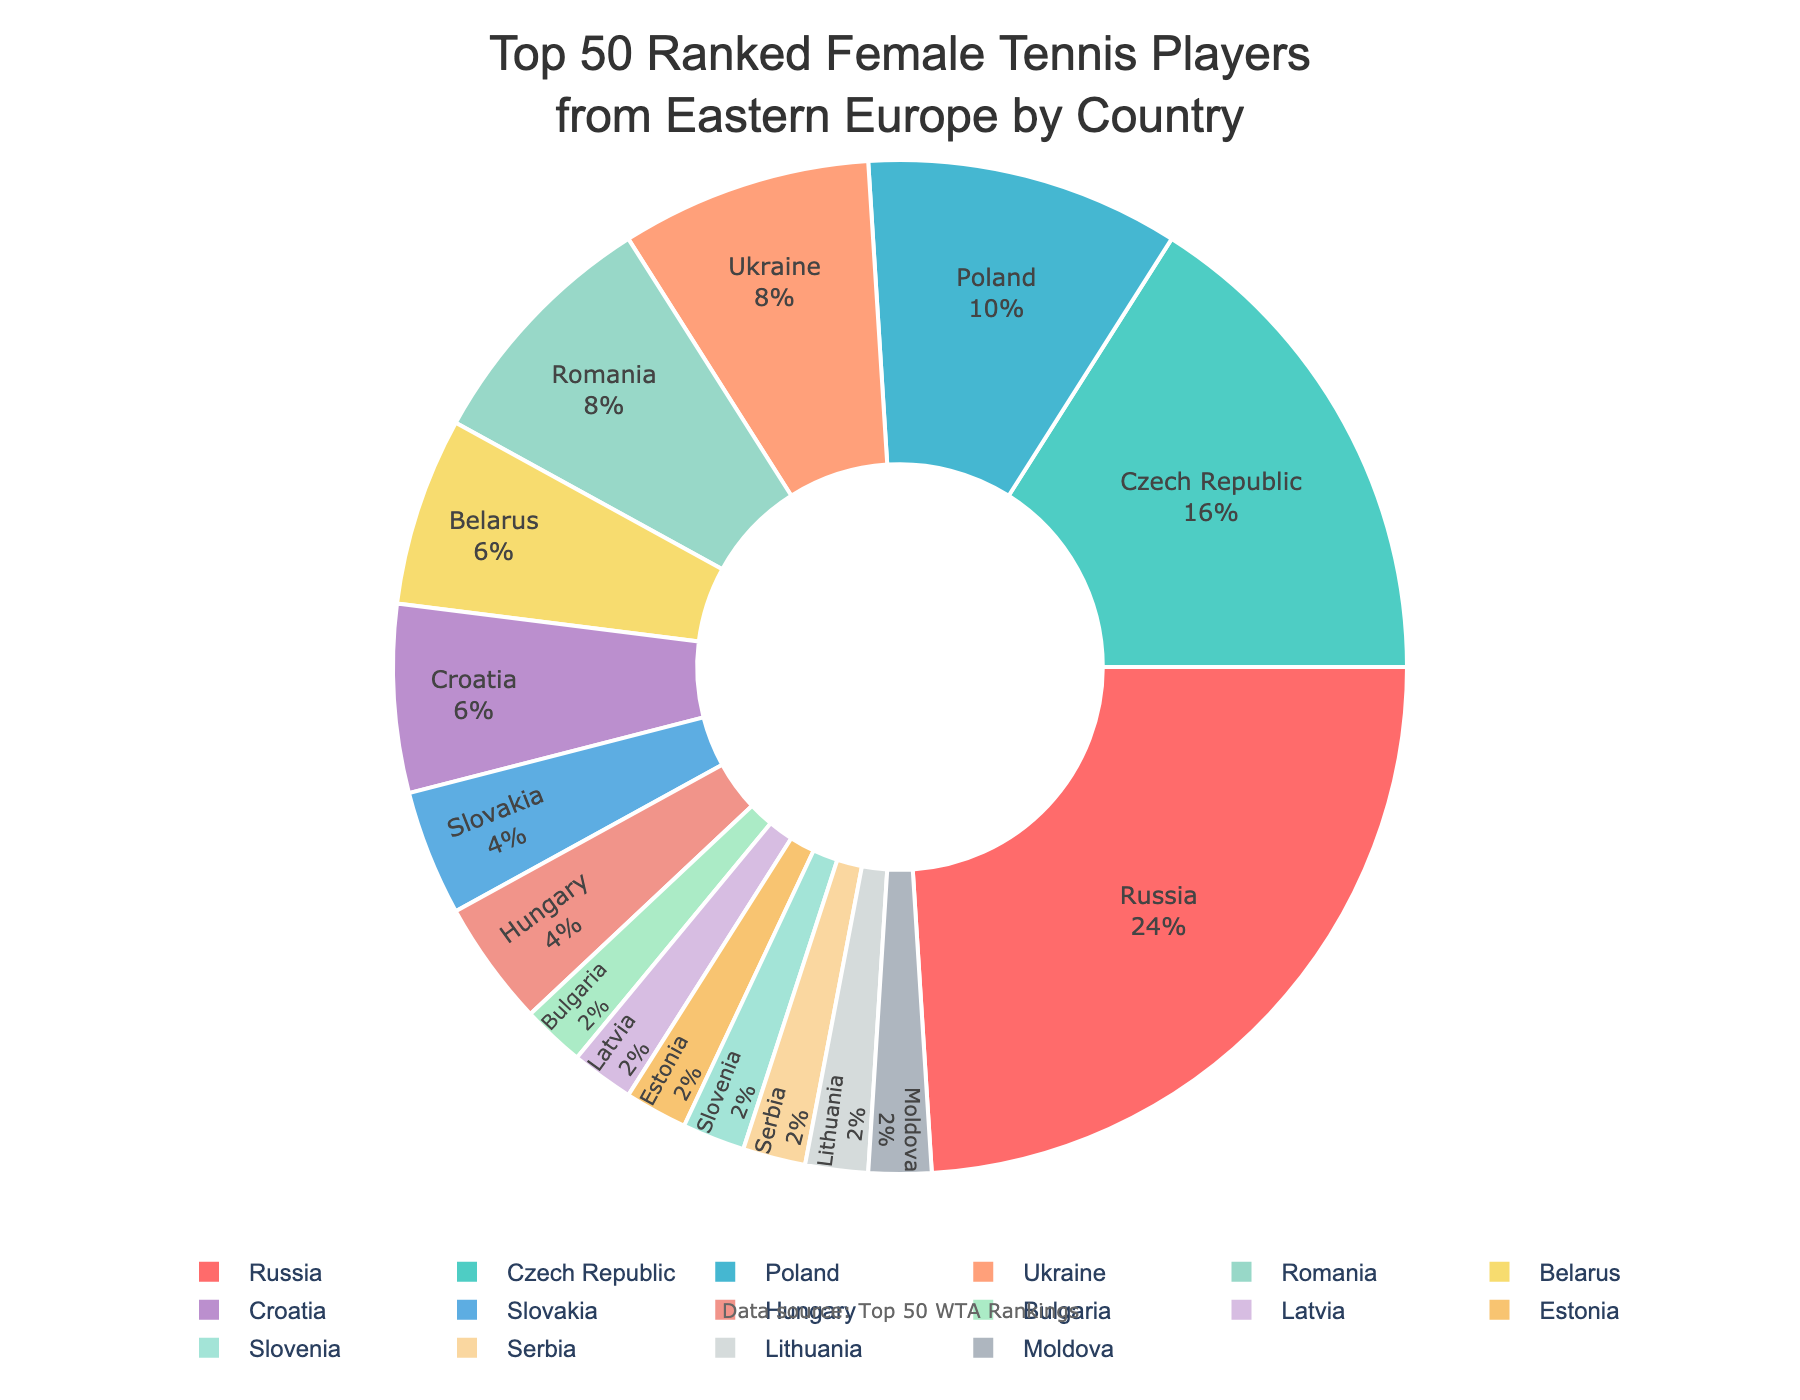Which country has the highest number of top 50 ranked female tennis players from Eastern Europe? From the pie chart, you can see that Russia has the largest section with 12 players.
Answer: Russia What percentage of top 50 ranked female tennis players from Eastern Europe come from Poland? The pie chart provides percentage labels for each country. Poland's section shows it has 5 players, which corresponds to approximately 10% of the total.
Answer: 10% How many more players does Russia have compared to Czech Republic? Based on the pie chart, Russia has 12 players and Czech Republic has 8 players. Subtracting the two: 12 - 8 = 4 players.
Answer: 4 What is the combined number of top 50 ranked female tennis players from Ukraine and Romania? From the pie chart, Ukraine has 4 players and Romania has 4 players. Adding them together: 4 + 4 = 8 players.
Answer: 8 How many Eastern European countries have exactly one player in the top 50? The pie chart shows that Bulgaria, Latvia, Estonia, Slovenia, Serbia, Lithuania, and Moldova each have 1 player, which sums up to 7 countries.
Answer: 7 Which country has more top 50 ranked female tennis players: Croatia or Belarus? By comparing the sections of the pie chart, Croatia has 3 players whereas Belarus also has 3 players. They have an equal number of players.
Answer: Equal What portion of the top 50 ranked female tennis players from Eastern Europe come from the countries with less than 3 players each? From the pie chart, the countries with less than 3 players each (Bulgaria, Latvia, Estonia, Slovenia, Serbia, Lithuania, Moldova) have 1 player each and Slovakia, Hungary have 2 players each: 7x1 + 2x2 = 11 players, out of 50. Calculating the portion: (11/50)*100 = 22%
Answer: 22% What is the median number of players per country among Eastern European countries in the top 50? List the number of players: [1, 1, 1, 1, 1, 1, 1, 2, 2, 3, 3, 3, 4, 4, 5, 8, 12]. The middle value in this ordered list is the median, which is 3.
Answer: 3 How does the number of players from Slovakia compare to that of Hungary? Slovakia has 2 players and Hungary also has 2 players, making them equal in number.
Answer: Equal 